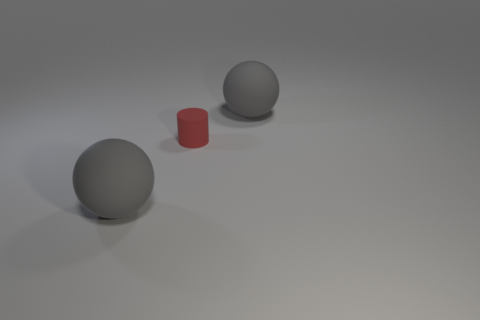Add 3 big matte spheres. How many objects exist? 6 Subtract 1 cylinders. How many cylinders are left? 0 Subtract all cylinders. How many objects are left? 2 Subtract all brown balls. Subtract all purple blocks. How many balls are left? 2 Subtract all small rubber cylinders. Subtract all tiny red matte blocks. How many objects are left? 2 Add 2 small red things. How many small red things are left? 3 Add 2 large matte spheres. How many large matte spheres exist? 4 Subtract 0 green balls. How many objects are left? 3 